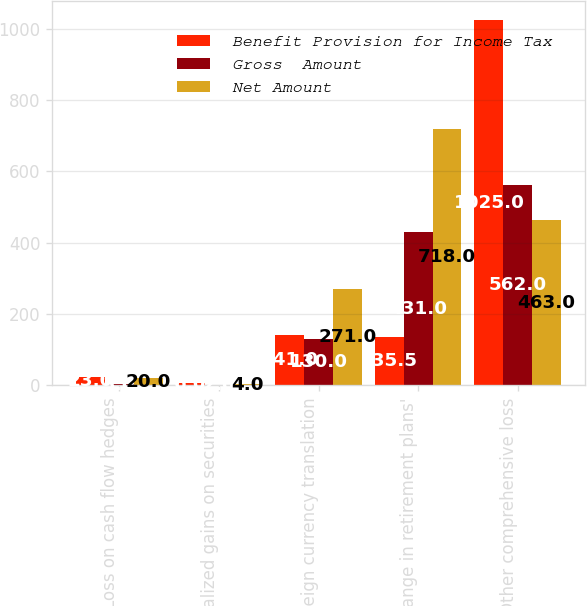Convert chart to OTSL. <chart><loc_0><loc_0><loc_500><loc_500><stacked_bar_chart><ecel><fcel>Loss on cash flow hedges<fcel>Unrealized gains on securities<fcel>Foreign currency translation<fcel>Change in retirement plans'<fcel>Other comprehensive loss<nl><fcel>Benefit Provision for Income Tax<fcel>23<fcel>6<fcel>141<fcel>135.5<fcel>1025<nl><fcel>Gross  Amount<fcel>3<fcel>2<fcel>130<fcel>431<fcel>562<nl><fcel>Net Amount<fcel>20<fcel>4<fcel>271<fcel>718<fcel>463<nl></chart> 